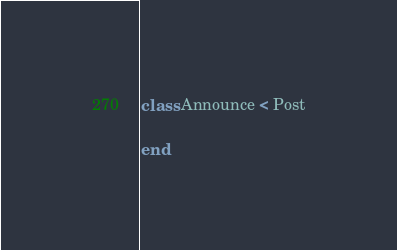Convert code to text. <code><loc_0><loc_0><loc_500><loc_500><_Ruby_>class Announce < Post

end

</code> 